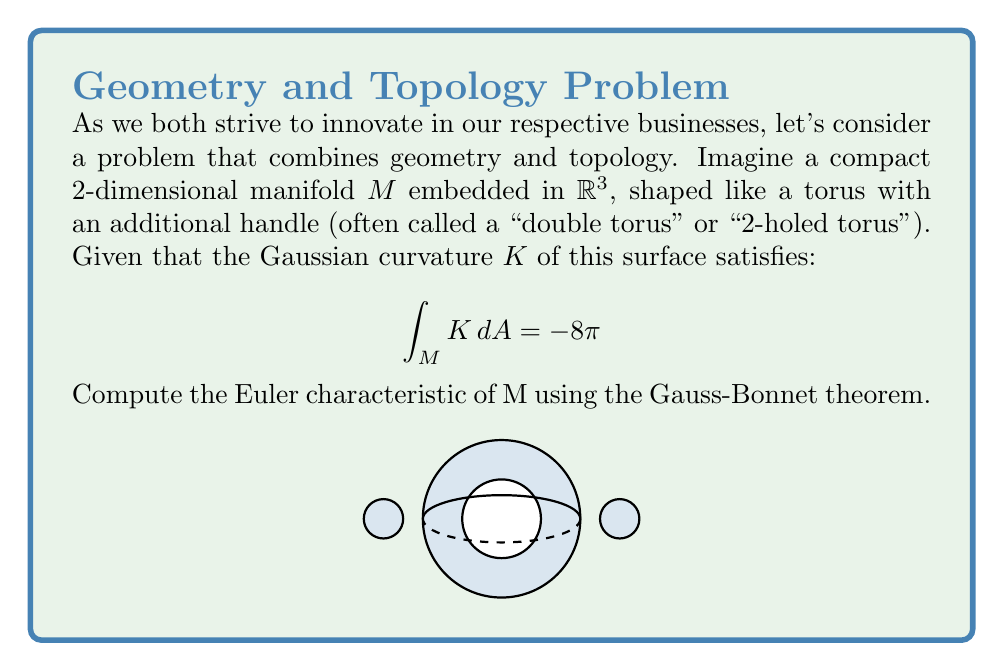Can you solve this math problem? Let's approach this step-by-step using the Gauss-Bonnet theorem:

1) The Gauss-Bonnet theorem for a compact 2-dimensional manifold $M$ without boundary states:

   $$\int_M K \, dA = 2\pi\chi(M)$$

   where $K$ is the Gaussian curvature and $\chi(M)$ is the Euler characteristic of $M$.

2) We are given that:

   $$\int_M K \, dA = -8\pi$$

3) Equating these two expressions:

   $$-8\pi = 2\pi\chi(M)$$

4) Solving for $\chi(M)$:

   $$\chi(M) = \frac{-8\pi}{2\pi} = -4$$

5) We can verify this result topologically:
   - A torus has Euler characteristic 0
   - Each additional handle decreases the Euler characteristic by 2
   - This surface has two handles, so: $0 - 2 - 2 = -4$

Thus, we have confirmed that the Euler characteristic is indeed -4.
Answer: $\chi(M) = -4$ 